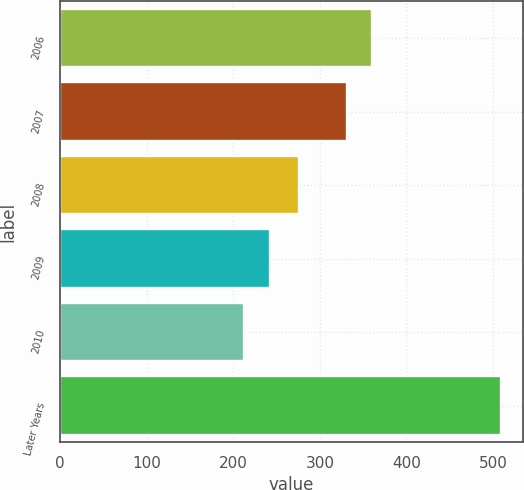Convert chart to OTSL. <chart><loc_0><loc_0><loc_500><loc_500><bar_chart><fcel>2006<fcel>2007<fcel>2008<fcel>2009<fcel>2010<fcel>Later Years<nl><fcel>360.6<fcel>331<fcel>276<fcel>242.6<fcel>213<fcel>509<nl></chart> 